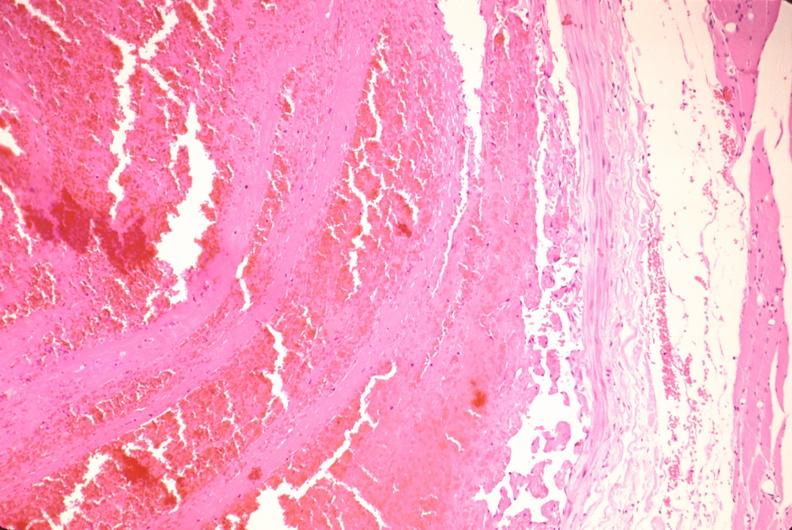what does this image show?
Answer the question using a single word or phrase. Thrombus in leg vein with early organization 